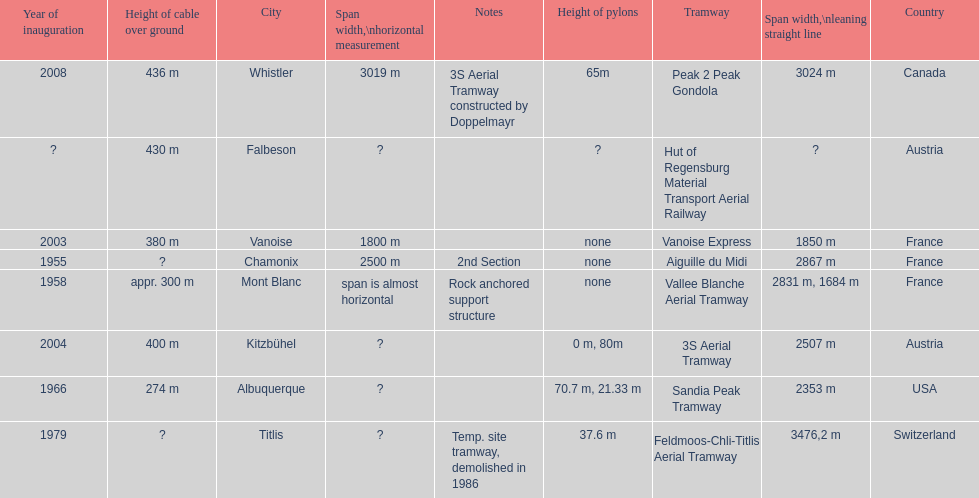At least how many aerial tramways were inaugurated after 1970? 4. 